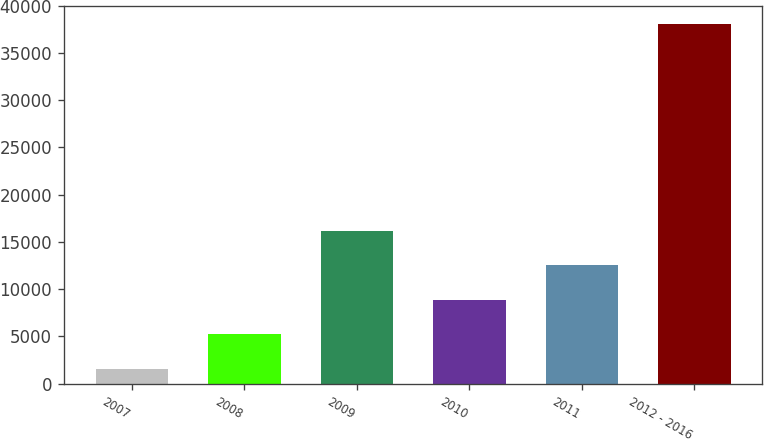Convert chart. <chart><loc_0><loc_0><loc_500><loc_500><bar_chart><fcel>2007<fcel>2008<fcel>2009<fcel>2010<fcel>2011<fcel>2012 - 2016<nl><fcel>1553<fcel>5208.6<fcel>16175.4<fcel>8864.2<fcel>12519.8<fcel>38109<nl></chart> 